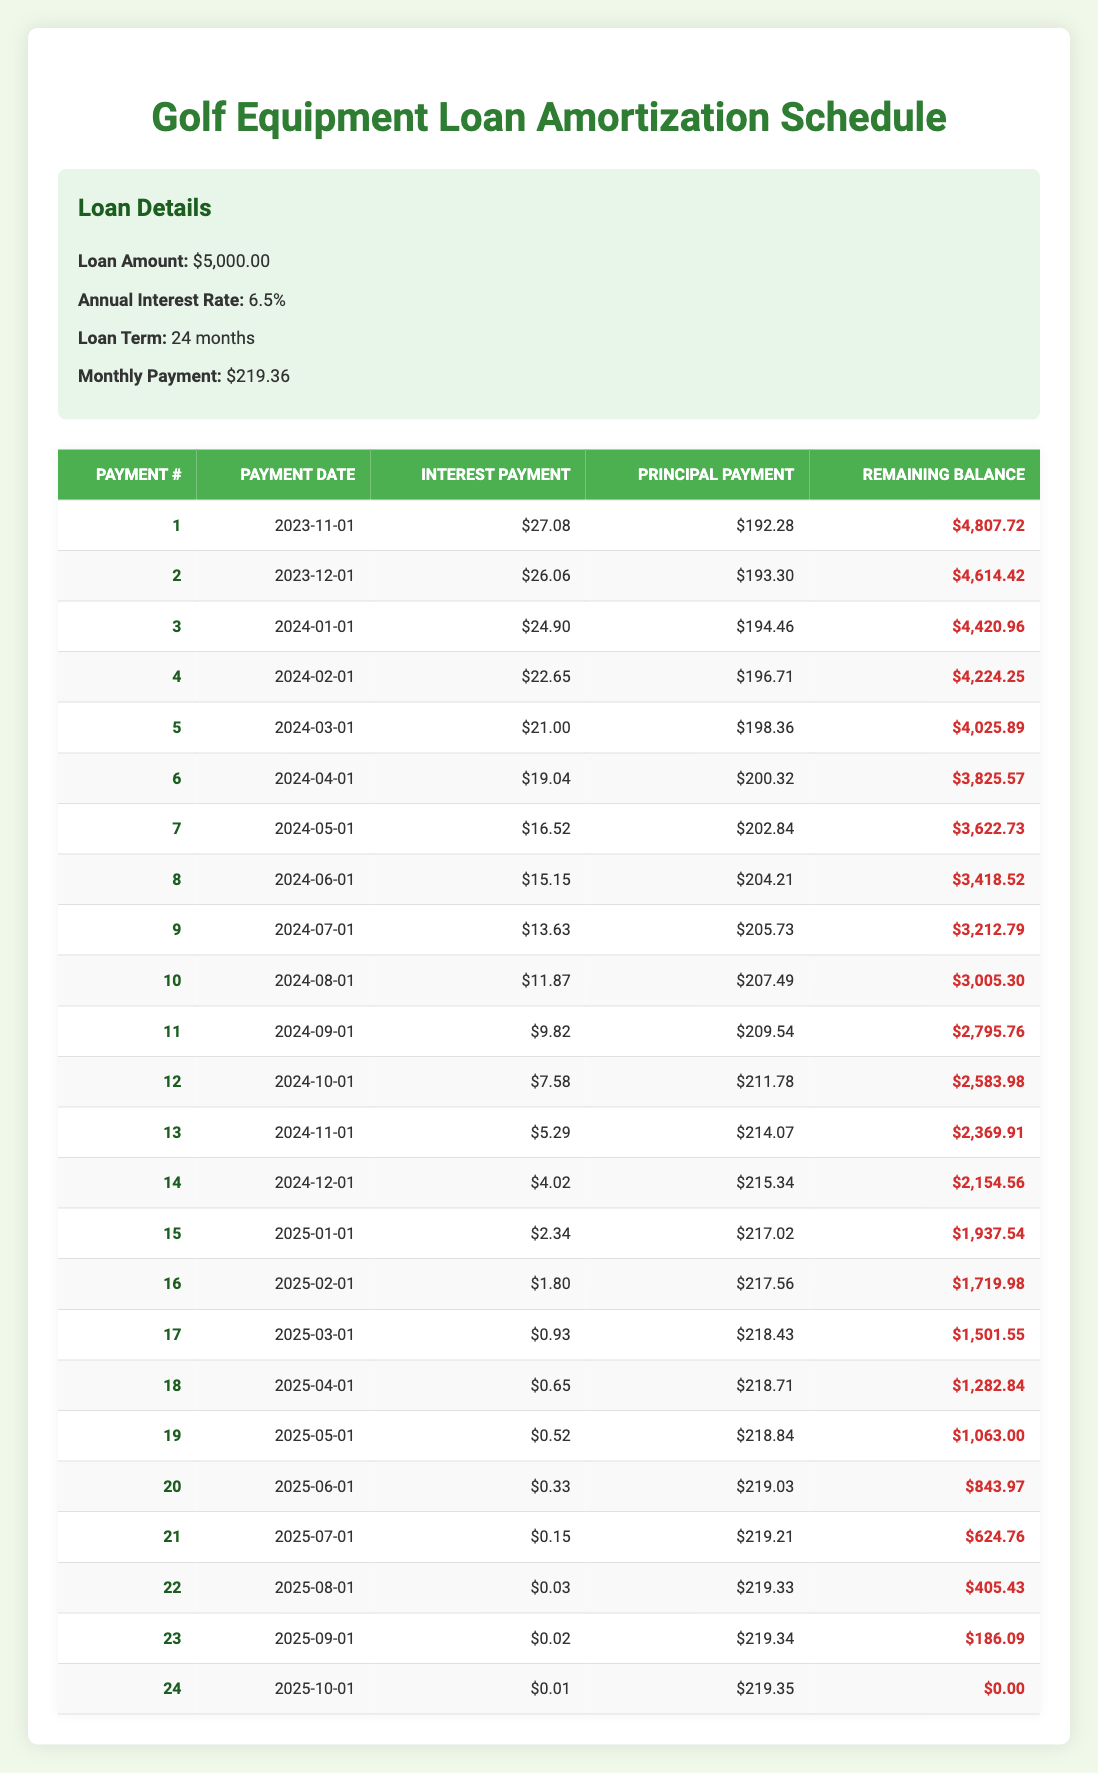What is the total loan amount? The loan amount is stated in the loan details section of the table, which shows a loan amount of $5,000.00.
Answer: 5000 How much is the monthly payment? The monthly payment is also provided in the loan details section of the table and is listed as $219.36.
Answer: 219.36 What is the interest payment of the first month? The first month's interest payment is shown in the amortization schedule under the first row, which indicates an interest payment of $27.08.
Answer: 27.08 How much principal is paid in the second month? In the second month's row of the amortization schedule, the principal payment is specified as $193.30.
Answer: 193.30 What is the remaining balance after the 12th payment? The remaining balance after the 12th payment is listed under the 12th row in the amortization schedule, which states that the remaining balance is $2,583.98.
Answer: 2583.98 What is the average principal payment for the first 5 months? The principal payments for the first five months are $192.28, $193.30, $194.46, $196.71, and $198.36. To find the average, sum these values (192.28 + 193.30 + 194.46 + 196.71 + 198.36 = 974.11) and divide by 5. The average principal payment is 974.11 / 5 = $194.82.
Answer: 194.82 Is the interest payment in the 10th month lower than in the 5th month? The interest payment for the 10th month is stated as $11.87, while the 5th month's interest payment is $21.00. Since $11.87 is less than $21.00, the answer is yes.
Answer: Yes How much total interest is paid over the full loan term? To find the total interest paid over the full term, sum all the interest payments for each month in the amortization schedule. The total amount equals $27.08 + $26.06 + $24.90 + $22.65 + $21.00 + $19.04 + $16.52 + $15.15 + $13.63 + $11.87 + $9.82 + $7.58 + $5.29 + $4.02 + $2.34 + $1.80 + $0.93 + $0.65 + $0.52 + $0.33 + $0.15 + $0.03 + $0.02 + $0.01 = $227.82.
Answer: 227.82 What is the difference in principal payment between the 23rd and 1st payment? The principal payment for the 1st payment is $192.28 and for the 23rd payment is $219.34. The difference is calculated as $219.34 - $192.28 = $27.06, indicating that the 23rd month's principal payment is higher.
Answer: 27.06 